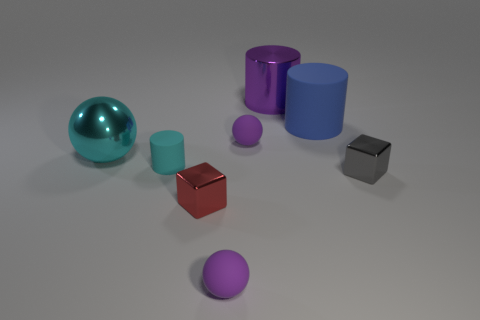How big is the purple metal thing?
Provide a succinct answer. Large. Is the number of tiny purple balls less than the number of big red metal balls?
Give a very brief answer. No. What number of large shiny cylinders have the same color as the tiny cylinder?
Your response must be concise. 0. Does the tiny ball behind the tiny cyan thing have the same color as the small matte cylinder?
Your response must be concise. No. There is a object in front of the tiny red thing; what shape is it?
Ensure brevity in your answer.  Sphere. Are there any small gray metallic things on the left side of the rubber cylinder that is behind the small cylinder?
Provide a succinct answer. No. What number of other small red blocks have the same material as the red block?
Your response must be concise. 0. There is a ball in front of the large object in front of the small purple sphere that is behind the cyan ball; what size is it?
Make the answer very short. Small. There is a tiny gray metallic block; what number of purple rubber objects are behind it?
Your response must be concise. 1. Are there more purple objects than big cyan spheres?
Your answer should be very brief. Yes. 